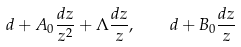Convert formula to latex. <formula><loc_0><loc_0><loc_500><loc_500>d + A _ { 0 } \frac { d z } { z ^ { 2 } } + \Lambda \frac { d z } { z } , \quad d + B _ { 0 } \frac { d z } { z }</formula> 